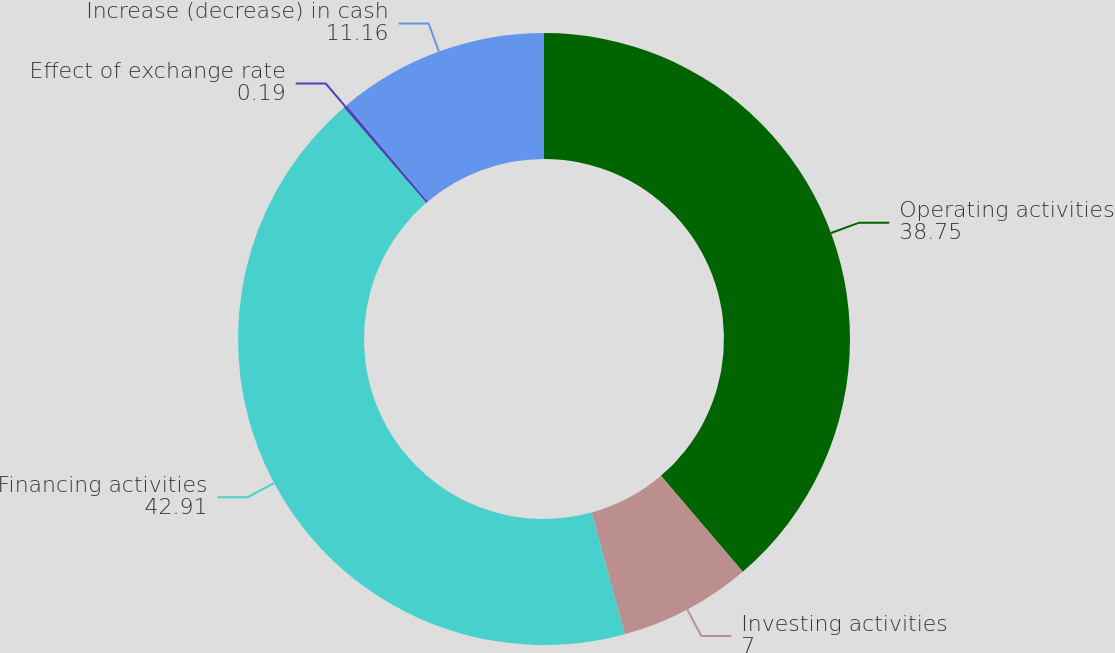<chart> <loc_0><loc_0><loc_500><loc_500><pie_chart><fcel>Operating activities<fcel>Investing activities<fcel>Financing activities<fcel>Effect of exchange rate<fcel>Increase (decrease) in cash<nl><fcel>38.75%<fcel>7.0%<fcel>42.91%<fcel>0.19%<fcel>11.16%<nl></chart> 